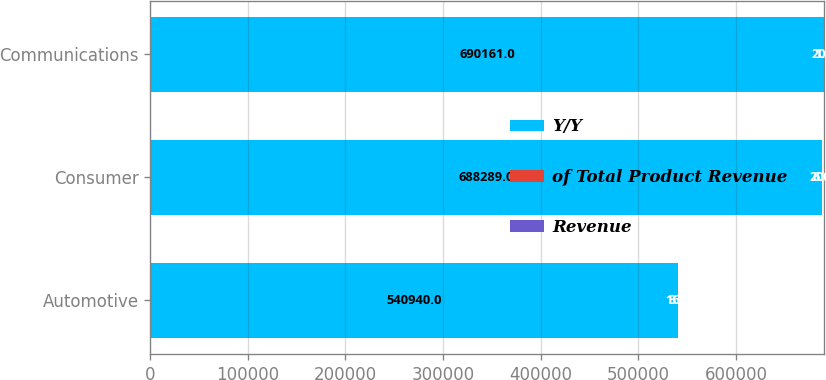Convert chart. <chart><loc_0><loc_0><loc_500><loc_500><stacked_bar_chart><ecel><fcel>Automotive<fcel>Consumer<fcel>Communications<nl><fcel>Y/Y<fcel>540940<fcel>688289<fcel>690161<nl><fcel>of Total Product Revenue<fcel>16<fcel>20<fcel>20<nl><fcel>Revenue<fcel>3<fcel>6<fcel>1<nl></chart> 